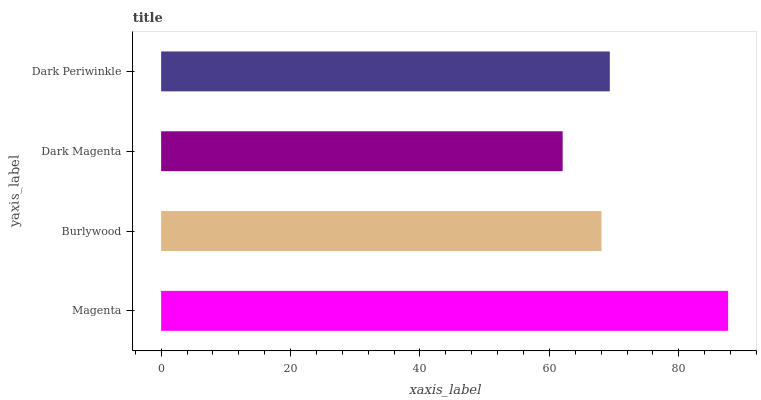Is Dark Magenta the minimum?
Answer yes or no. Yes. Is Magenta the maximum?
Answer yes or no. Yes. Is Burlywood the minimum?
Answer yes or no. No. Is Burlywood the maximum?
Answer yes or no. No. Is Magenta greater than Burlywood?
Answer yes or no. Yes. Is Burlywood less than Magenta?
Answer yes or no. Yes. Is Burlywood greater than Magenta?
Answer yes or no. No. Is Magenta less than Burlywood?
Answer yes or no. No. Is Dark Periwinkle the high median?
Answer yes or no. Yes. Is Burlywood the low median?
Answer yes or no. Yes. Is Dark Magenta the high median?
Answer yes or no. No. Is Dark Periwinkle the low median?
Answer yes or no. No. 